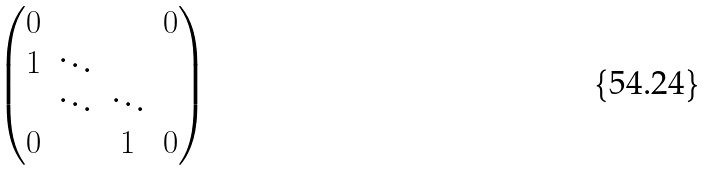Convert formula to latex. <formula><loc_0><loc_0><loc_500><loc_500>\begin{pmatrix} 0 & & & 0 \\ 1 & \ddots & & \\ & \ddots & \ddots & \\ 0 & & 1 & 0 \end{pmatrix}</formula> 